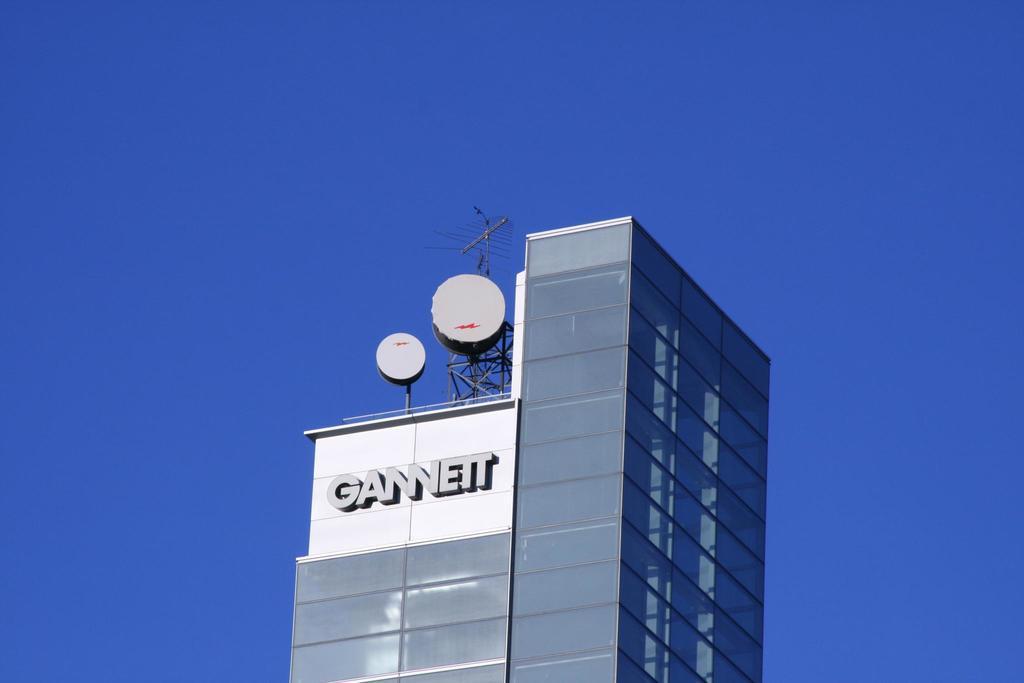Can you describe this image briefly? In this image, we can see a glass building. Here we can see few objects, antenna. Background there is a clear sky. 